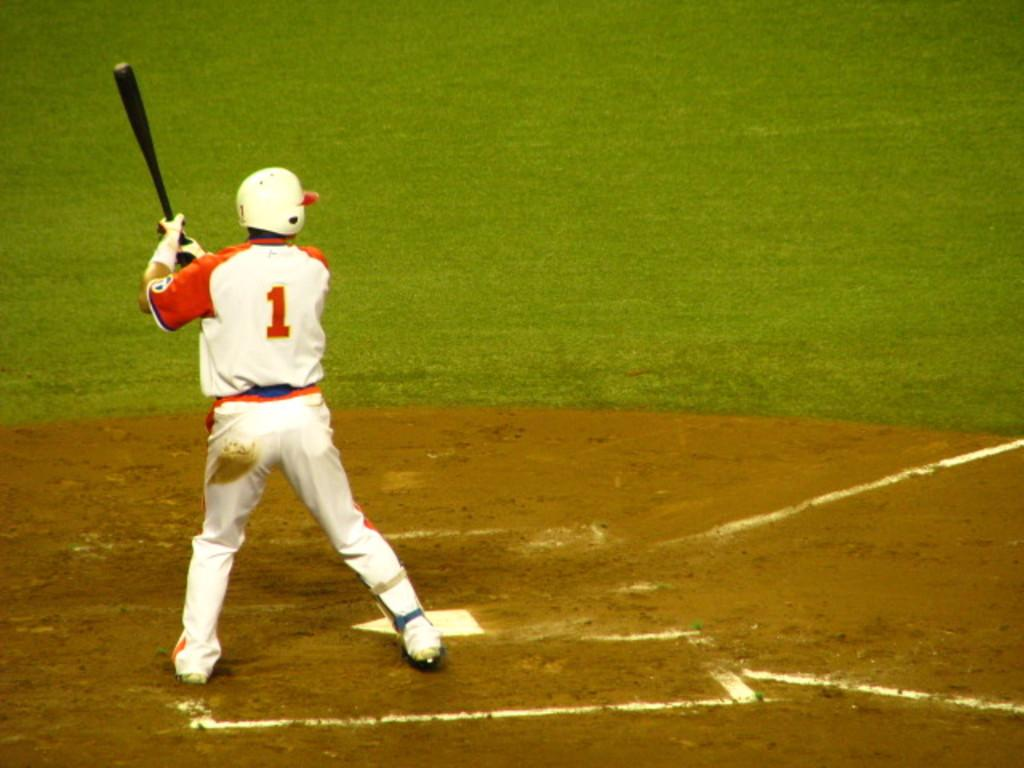Who is present in the image? There is a man in the image. What is the man doing in the image? The man is standing on the ground and holding a baseball bat. What type of surface is the man standing on? The land around the man is covered with grass. What type of sack can be seen in the image? There is no sack present in the image. What kind of rice is being grown on the grassy land in the image? There is no rice being grown in the image; the land is covered with grass. 